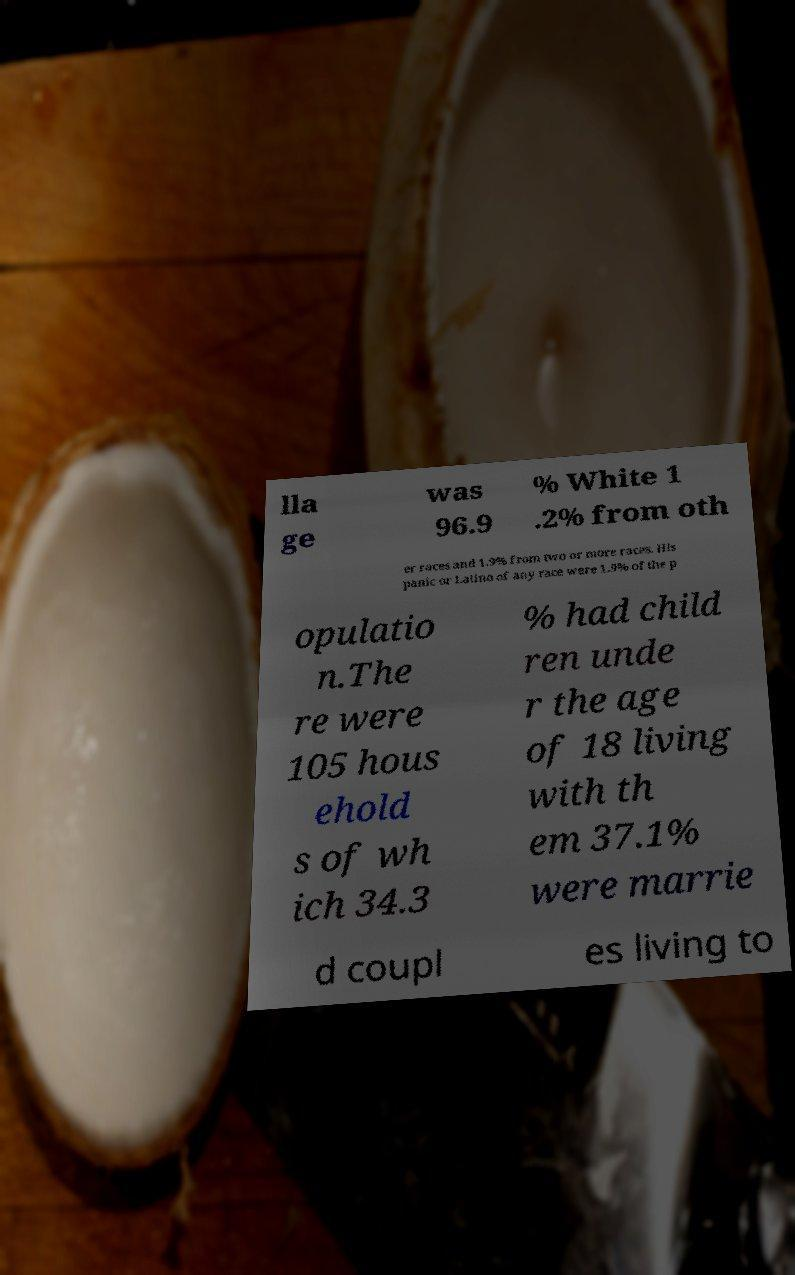Could you extract and type out the text from this image? lla ge was 96.9 % White 1 .2% from oth er races and 1.9% from two or more races. His panic or Latino of any race were 1.9% of the p opulatio n.The re were 105 hous ehold s of wh ich 34.3 % had child ren unde r the age of 18 living with th em 37.1% were marrie d coupl es living to 